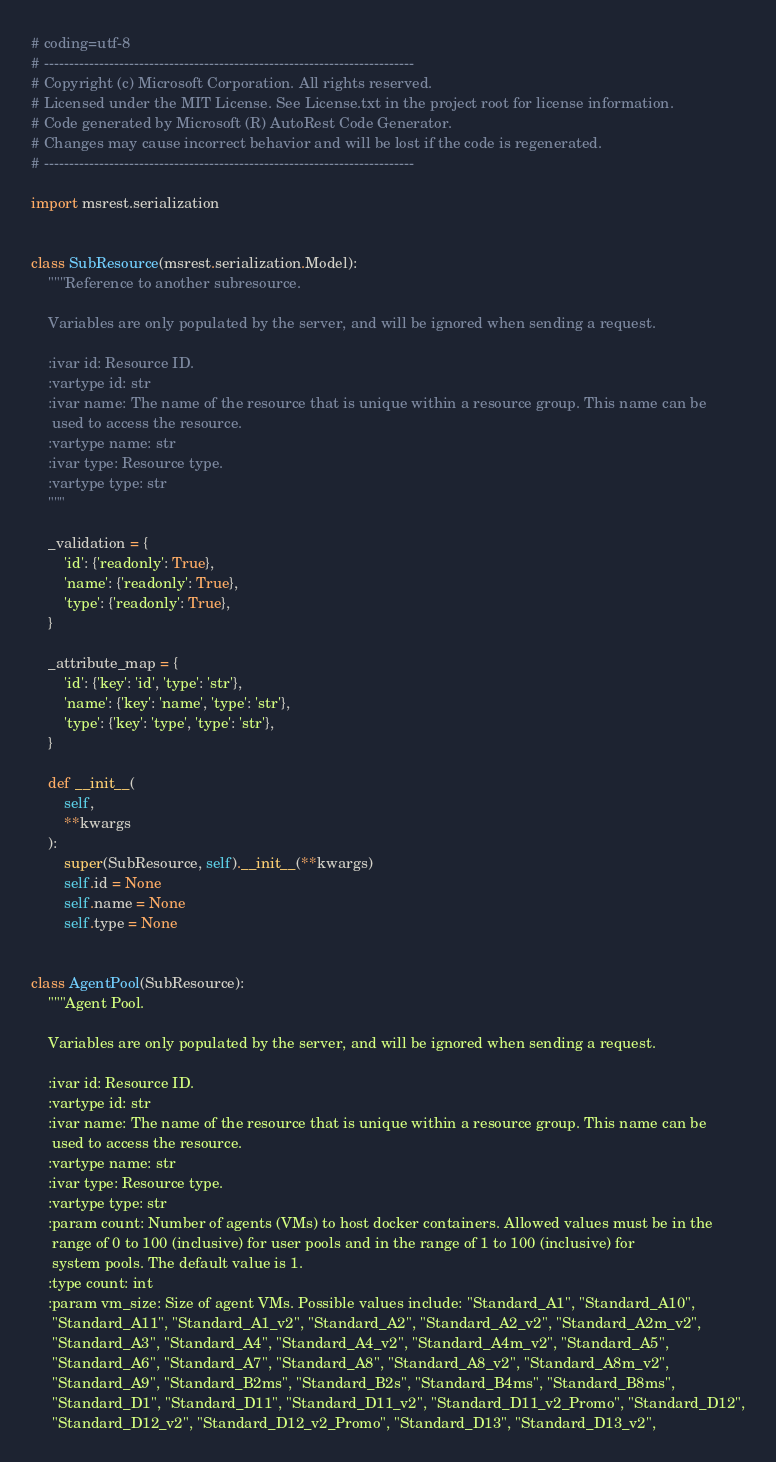<code> <loc_0><loc_0><loc_500><loc_500><_Python_># coding=utf-8
# --------------------------------------------------------------------------
# Copyright (c) Microsoft Corporation. All rights reserved.
# Licensed under the MIT License. See License.txt in the project root for license information.
# Code generated by Microsoft (R) AutoRest Code Generator.
# Changes may cause incorrect behavior and will be lost if the code is regenerated.
# --------------------------------------------------------------------------

import msrest.serialization


class SubResource(msrest.serialization.Model):
    """Reference to another subresource.

    Variables are only populated by the server, and will be ignored when sending a request.

    :ivar id: Resource ID.
    :vartype id: str
    :ivar name: The name of the resource that is unique within a resource group. This name can be
     used to access the resource.
    :vartype name: str
    :ivar type: Resource type.
    :vartype type: str
    """

    _validation = {
        'id': {'readonly': True},
        'name': {'readonly': True},
        'type': {'readonly': True},
    }

    _attribute_map = {
        'id': {'key': 'id', 'type': 'str'},
        'name': {'key': 'name', 'type': 'str'},
        'type': {'key': 'type', 'type': 'str'},
    }

    def __init__(
        self,
        **kwargs
    ):
        super(SubResource, self).__init__(**kwargs)
        self.id = None
        self.name = None
        self.type = None


class AgentPool(SubResource):
    """Agent Pool.

    Variables are only populated by the server, and will be ignored when sending a request.

    :ivar id: Resource ID.
    :vartype id: str
    :ivar name: The name of the resource that is unique within a resource group. This name can be
     used to access the resource.
    :vartype name: str
    :ivar type: Resource type.
    :vartype type: str
    :param count: Number of agents (VMs) to host docker containers. Allowed values must be in the
     range of 0 to 100 (inclusive) for user pools and in the range of 1 to 100 (inclusive) for
     system pools. The default value is 1.
    :type count: int
    :param vm_size: Size of agent VMs. Possible values include: "Standard_A1", "Standard_A10",
     "Standard_A11", "Standard_A1_v2", "Standard_A2", "Standard_A2_v2", "Standard_A2m_v2",
     "Standard_A3", "Standard_A4", "Standard_A4_v2", "Standard_A4m_v2", "Standard_A5",
     "Standard_A6", "Standard_A7", "Standard_A8", "Standard_A8_v2", "Standard_A8m_v2",
     "Standard_A9", "Standard_B2ms", "Standard_B2s", "Standard_B4ms", "Standard_B8ms",
     "Standard_D1", "Standard_D11", "Standard_D11_v2", "Standard_D11_v2_Promo", "Standard_D12",
     "Standard_D12_v2", "Standard_D12_v2_Promo", "Standard_D13", "Standard_D13_v2",</code> 